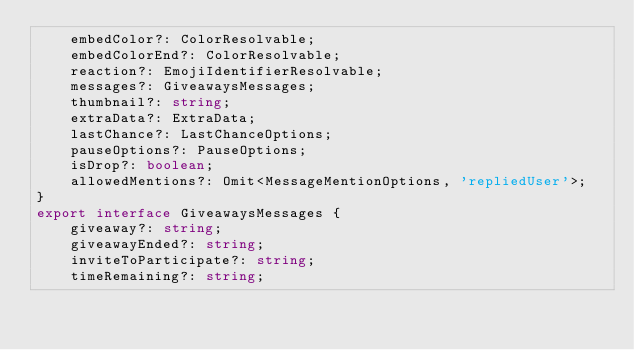Convert code to text. <code><loc_0><loc_0><loc_500><loc_500><_TypeScript_>    embedColor?: ColorResolvable;
    embedColorEnd?: ColorResolvable;
    reaction?: EmojiIdentifierResolvable;
    messages?: GiveawaysMessages;
    thumbnail?: string;
    extraData?: ExtraData;
    lastChance?: LastChanceOptions;
    pauseOptions?: PauseOptions;
    isDrop?: boolean;
    allowedMentions?: Omit<MessageMentionOptions, 'repliedUser'>;
}
export interface GiveawaysMessages {
    giveaway?: string;
    giveawayEnded?: string;
    inviteToParticipate?: string;
    timeRemaining?: string;</code> 